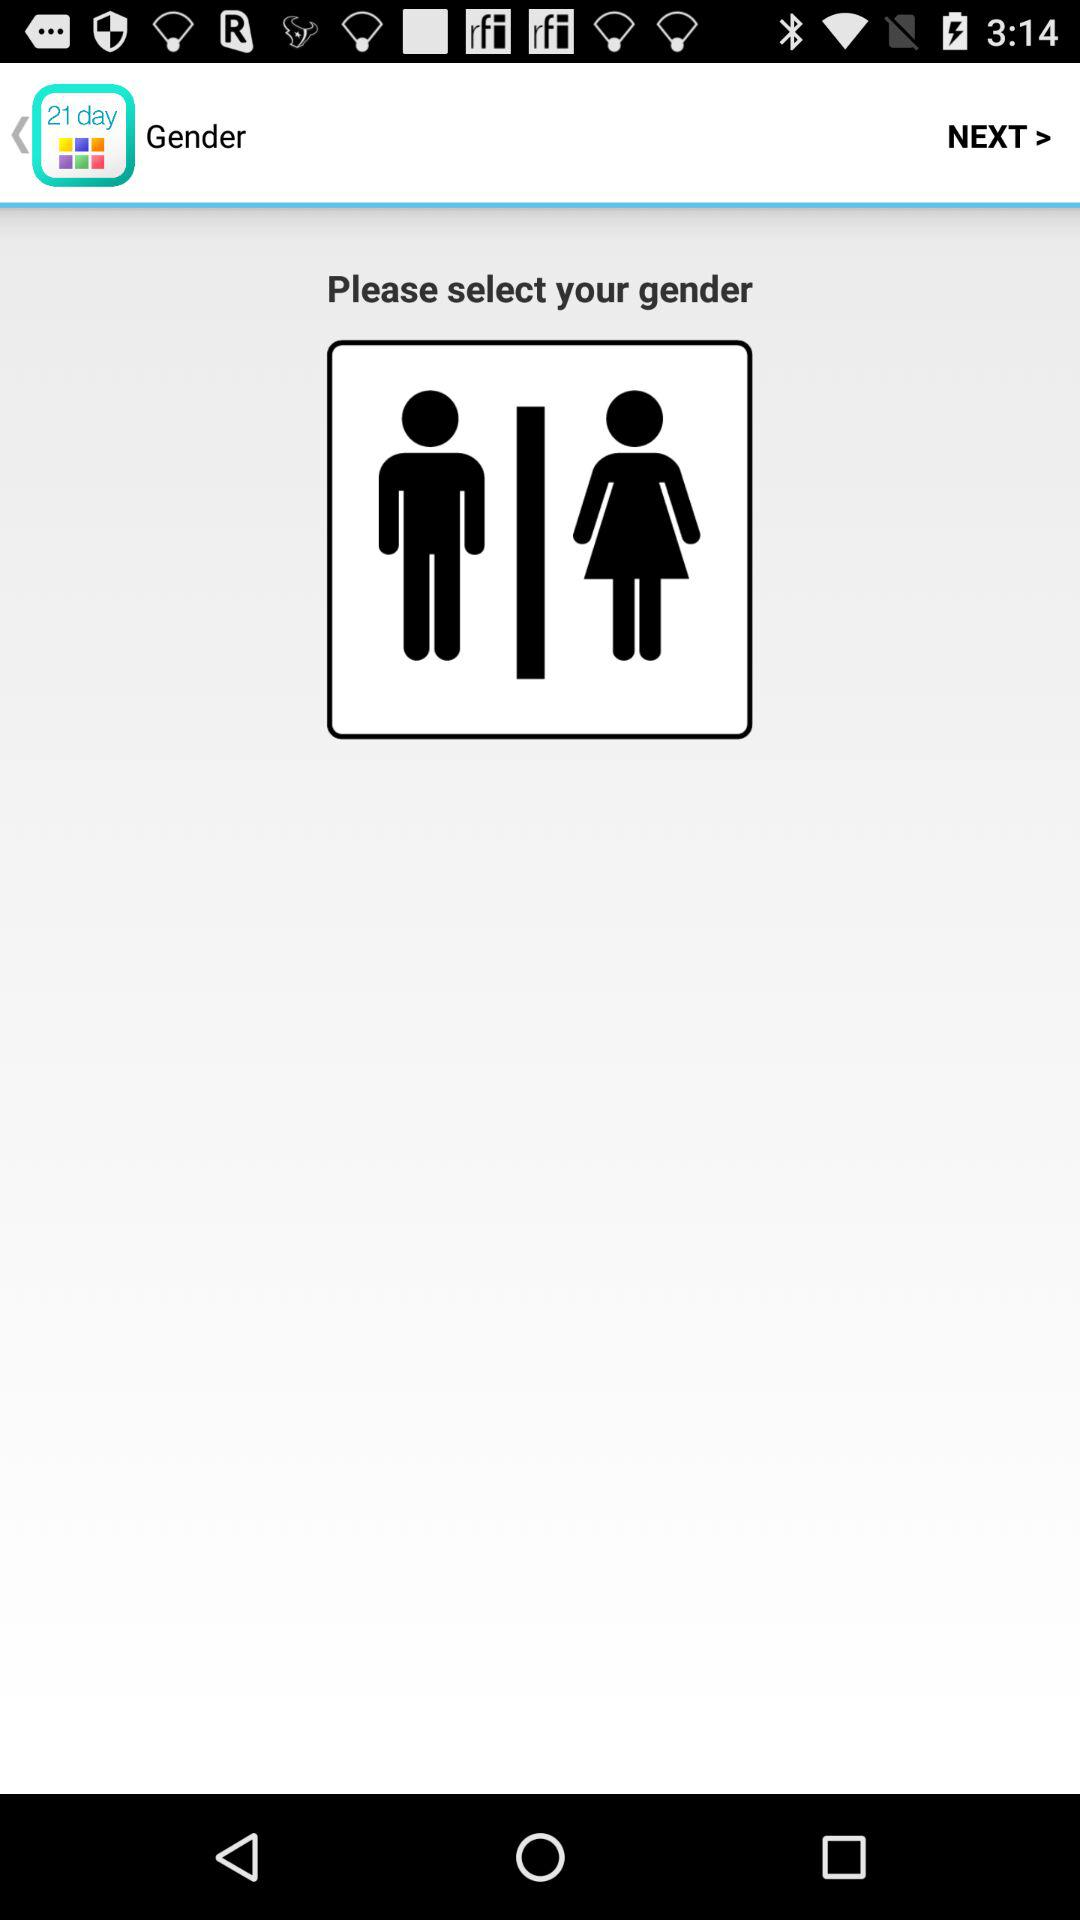How many different gender options are there?
Answer the question using a single word or phrase. 2 